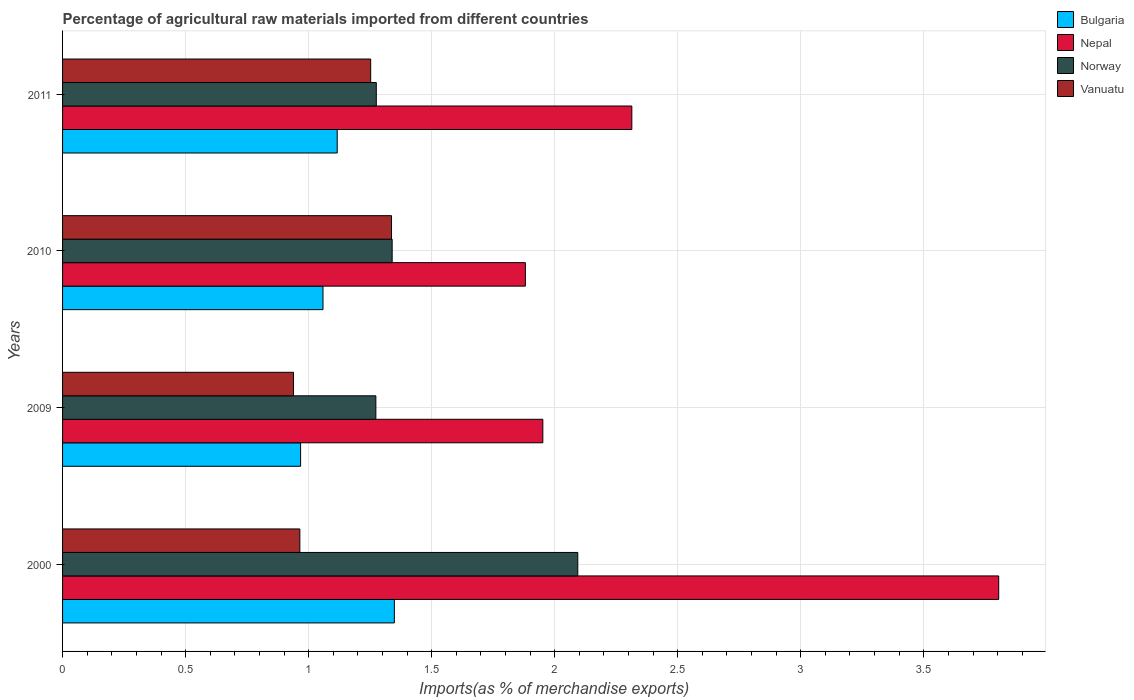How many different coloured bars are there?
Your answer should be very brief. 4. How many groups of bars are there?
Keep it short and to the point. 4. Are the number of bars per tick equal to the number of legend labels?
Make the answer very short. Yes. How many bars are there on the 2nd tick from the top?
Your response must be concise. 4. How many bars are there on the 1st tick from the bottom?
Give a very brief answer. 4. What is the label of the 2nd group of bars from the top?
Keep it short and to the point. 2010. In how many cases, is the number of bars for a given year not equal to the number of legend labels?
Offer a terse response. 0. What is the percentage of imports to different countries in Vanuatu in 2009?
Your answer should be very brief. 0.94. Across all years, what is the maximum percentage of imports to different countries in Nepal?
Offer a very short reply. 3.8. Across all years, what is the minimum percentage of imports to different countries in Vanuatu?
Your answer should be very brief. 0.94. In which year was the percentage of imports to different countries in Vanuatu minimum?
Keep it short and to the point. 2009. What is the total percentage of imports to different countries in Vanuatu in the graph?
Give a very brief answer. 4.49. What is the difference between the percentage of imports to different countries in Bulgaria in 2000 and that in 2011?
Ensure brevity in your answer.  0.23. What is the difference between the percentage of imports to different countries in Bulgaria in 2009 and the percentage of imports to different countries in Norway in 2011?
Your answer should be very brief. -0.31. What is the average percentage of imports to different countries in Norway per year?
Make the answer very short. 1.5. In the year 2000, what is the difference between the percentage of imports to different countries in Bulgaria and percentage of imports to different countries in Norway?
Provide a succinct answer. -0.75. What is the ratio of the percentage of imports to different countries in Norway in 2000 to that in 2009?
Keep it short and to the point. 1.64. Is the percentage of imports to different countries in Bulgaria in 2000 less than that in 2011?
Ensure brevity in your answer.  No. Is the difference between the percentage of imports to different countries in Bulgaria in 2009 and 2011 greater than the difference between the percentage of imports to different countries in Norway in 2009 and 2011?
Provide a short and direct response. No. What is the difference between the highest and the second highest percentage of imports to different countries in Nepal?
Ensure brevity in your answer.  1.49. What is the difference between the highest and the lowest percentage of imports to different countries in Nepal?
Your answer should be very brief. 1.92. What does the 3rd bar from the top in 2010 represents?
Provide a short and direct response. Nepal. How many years are there in the graph?
Ensure brevity in your answer.  4. Does the graph contain any zero values?
Offer a very short reply. No. Does the graph contain grids?
Keep it short and to the point. Yes. Where does the legend appear in the graph?
Offer a terse response. Top right. How many legend labels are there?
Keep it short and to the point. 4. How are the legend labels stacked?
Your answer should be compact. Vertical. What is the title of the graph?
Offer a very short reply. Percentage of agricultural raw materials imported from different countries. Does "Eritrea" appear as one of the legend labels in the graph?
Ensure brevity in your answer.  No. What is the label or title of the X-axis?
Your response must be concise. Imports(as % of merchandise exports). What is the label or title of the Y-axis?
Make the answer very short. Years. What is the Imports(as % of merchandise exports) in Bulgaria in 2000?
Make the answer very short. 1.35. What is the Imports(as % of merchandise exports) in Nepal in 2000?
Your answer should be very brief. 3.8. What is the Imports(as % of merchandise exports) of Norway in 2000?
Give a very brief answer. 2.09. What is the Imports(as % of merchandise exports) in Vanuatu in 2000?
Your answer should be very brief. 0.96. What is the Imports(as % of merchandise exports) in Bulgaria in 2009?
Provide a short and direct response. 0.97. What is the Imports(as % of merchandise exports) in Nepal in 2009?
Provide a short and direct response. 1.95. What is the Imports(as % of merchandise exports) in Norway in 2009?
Your response must be concise. 1.27. What is the Imports(as % of merchandise exports) in Vanuatu in 2009?
Offer a terse response. 0.94. What is the Imports(as % of merchandise exports) of Bulgaria in 2010?
Offer a terse response. 1.06. What is the Imports(as % of merchandise exports) in Nepal in 2010?
Ensure brevity in your answer.  1.88. What is the Imports(as % of merchandise exports) in Norway in 2010?
Provide a succinct answer. 1.34. What is the Imports(as % of merchandise exports) of Vanuatu in 2010?
Offer a very short reply. 1.34. What is the Imports(as % of merchandise exports) in Bulgaria in 2011?
Provide a succinct answer. 1.12. What is the Imports(as % of merchandise exports) of Nepal in 2011?
Your answer should be very brief. 2.31. What is the Imports(as % of merchandise exports) of Norway in 2011?
Provide a short and direct response. 1.27. What is the Imports(as % of merchandise exports) of Vanuatu in 2011?
Make the answer very short. 1.25. Across all years, what is the maximum Imports(as % of merchandise exports) of Bulgaria?
Give a very brief answer. 1.35. Across all years, what is the maximum Imports(as % of merchandise exports) in Nepal?
Make the answer very short. 3.8. Across all years, what is the maximum Imports(as % of merchandise exports) of Norway?
Offer a terse response. 2.09. Across all years, what is the maximum Imports(as % of merchandise exports) of Vanuatu?
Your answer should be very brief. 1.34. Across all years, what is the minimum Imports(as % of merchandise exports) of Bulgaria?
Offer a very short reply. 0.97. Across all years, what is the minimum Imports(as % of merchandise exports) of Nepal?
Your answer should be compact. 1.88. Across all years, what is the minimum Imports(as % of merchandise exports) in Norway?
Offer a very short reply. 1.27. Across all years, what is the minimum Imports(as % of merchandise exports) of Vanuatu?
Provide a short and direct response. 0.94. What is the total Imports(as % of merchandise exports) of Bulgaria in the graph?
Give a very brief answer. 4.49. What is the total Imports(as % of merchandise exports) of Nepal in the graph?
Give a very brief answer. 9.95. What is the total Imports(as % of merchandise exports) in Norway in the graph?
Your answer should be compact. 5.98. What is the total Imports(as % of merchandise exports) in Vanuatu in the graph?
Make the answer very short. 4.49. What is the difference between the Imports(as % of merchandise exports) in Bulgaria in 2000 and that in 2009?
Ensure brevity in your answer.  0.38. What is the difference between the Imports(as % of merchandise exports) in Nepal in 2000 and that in 2009?
Your answer should be compact. 1.85. What is the difference between the Imports(as % of merchandise exports) of Norway in 2000 and that in 2009?
Your answer should be compact. 0.82. What is the difference between the Imports(as % of merchandise exports) in Vanuatu in 2000 and that in 2009?
Give a very brief answer. 0.03. What is the difference between the Imports(as % of merchandise exports) of Bulgaria in 2000 and that in 2010?
Offer a very short reply. 0.29. What is the difference between the Imports(as % of merchandise exports) of Nepal in 2000 and that in 2010?
Provide a succinct answer. 1.92. What is the difference between the Imports(as % of merchandise exports) in Norway in 2000 and that in 2010?
Your answer should be compact. 0.75. What is the difference between the Imports(as % of merchandise exports) in Vanuatu in 2000 and that in 2010?
Make the answer very short. -0.37. What is the difference between the Imports(as % of merchandise exports) of Bulgaria in 2000 and that in 2011?
Your response must be concise. 0.23. What is the difference between the Imports(as % of merchandise exports) in Nepal in 2000 and that in 2011?
Your answer should be very brief. 1.49. What is the difference between the Imports(as % of merchandise exports) of Norway in 2000 and that in 2011?
Provide a short and direct response. 0.82. What is the difference between the Imports(as % of merchandise exports) in Vanuatu in 2000 and that in 2011?
Provide a succinct answer. -0.29. What is the difference between the Imports(as % of merchandise exports) of Bulgaria in 2009 and that in 2010?
Give a very brief answer. -0.09. What is the difference between the Imports(as % of merchandise exports) in Nepal in 2009 and that in 2010?
Offer a terse response. 0.07. What is the difference between the Imports(as % of merchandise exports) of Norway in 2009 and that in 2010?
Make the answer very short. -0.07. What is the difference between the Imports(as % of merchandise exports) in Vanuatu in 2009 and that in 2010?
Offer a terse response. -0.4. What is the difference between the Imports(as % of merchandise exports) in Bulgaria in 2009 and that in 2011?
Keep it short and to the point. -0.15. What is the difference between the Imports(as % of merchandise exports) in Nepal in 2009 and that in 2011?
Provide a succinct answer. -0.36. What is the difference between the Imports(as % of merchandise exports) in Norway in 2009 and that in 2011?
Make the answer very short. -0. What is the difference between the Imports(as % of merchandise exports) of Vanuatu in 2009 and that in 2011?
Your answer should be very brief. -0.31. What is the difference between the Imports(as % of merchandise exports) of Bulgaria in 2010 and that in 2011?
Give a very brief answer. -0.06. What is the difference between the Imports(as % of merchandise exports) of Nepal in 2010 and that in 2011?
Offer a terse response. -0.43. What is the difference between the Imports(as % of merchandise exports) of Norway in 2010 and that in 2011?
Your answer should be compact. 0.06. What is the difference between the Imports(as % of merchandise exports) of Vanuatu in 2010 and that in 2011?
Ensure brevity in your answer.  0.08. What is the difference between the Imports(as % of merchandise exports) of Bulgaria in 2000 and the Imports(as % of merchandise exports) of Nepal in 2009?
Ensure brevity in your answer.  -0.6. What is the difference between the Imports(as % of merchandise exports) of Bulgaria in 2000 and the Imports(as % of merchandise exports) of Norway in 2009?
Your answer should be very brief. 0.08. What is the difference between the Imports(as % of merchandise exports) in Bulgaria in 2000 and the Imports(as % of merchandise exports) in Vanuatu in 2009?
Give a very brief answer. 0.41. What is the difference between the Imports(as % of merchandise exports) of Nepal in 2000 and the Imports(as % of merchandise exports) of Norway in 2009?
Provide a short and direct response. 2.53. What is the difference between the Imports(as % of merchandise exports) of Nepal in 2000 and the Imports(as % of merchandise exports) of Vanuatu in 2009?
Ensure brevity in your answer.  2.87. What is the difference between the Imports(as % of merchandise exports) of Norway in 2000 and the Imports(as % of merchandise exports) of Vanuatu in 2009?
Your answer should be compact. 1.16. What is the difference between the Imports(as % of merchandise exports) in Bulgaria in 2000 and the Imports(as % of merchandise exports) in Nepal in 2010?
Offer a very short reply. -0.53. What is the difference between the Imports(as % of merchandise exports) of Bulgaria in 2000 and the Imports(as % of merchandise exports) of Norway in 2010?
Make the answer very short. 0.01. What is the difference between the Imports(as % of merchandise exports) in Bulgaria in 2000 and the Imports(as % of merchandise exports) in Vanuatu in 2010?
Ensure brevity in your answer.  0.01. What is the difference between the Imports(as % of merchandise exports) of Nepal in 2000 and the Imports(as % of merchandise exports) of Norway in 2010?
Make the answer very short. 2.46. What is the difference between the Imports(as % of merchandise exports) in Nepal in 2000 and the Imports(as % of merchandise exports) in Vanuatu in 2010?
Make the answer very short. 2.47. What is the difference between the Imports(as % of merchandise exports) in Norway in 2000 and the Imports(as % of merchandise exports) in Vanuatu in 2010?
Make the answer very short. 0.76. What is the difference between the Imports(as % of merchandise exports) of Bulgaria in 2000 and the Imports(as % of merchandise exports) of Nepal in 2011?
Provide a short and direct response. -0.97. What is the difference between the Imports(as % of merchandise exports) of Bulgaria in 2000 and the Imports(as % of merchandise exports) of Norway in 2011?
Give a very brief answer. 0.07. What is the difference between the Imports(as % of merchandise exports) in Bulgaria in 2000 and the Imports(as % of merchandise exports) in Vanuatu in 2011?
Your answer should be very brief. 0.1. What is the difference between the Imports(as % of merchandise exports) of Nepal in 2000 and the Imports(as % of merchandise exports) of Norway in 2011?
Your answer should be very brief. 2.53. What is the difference between the Imports(as % of merchandise exports) of Nepal in 2000 and the Imports(as % of merchandise exports) of Vanuatu in 2011?
Provide a short and direct response. 2.55. What is the difference between the Imports(as % of merchandise exports) of Norway in 2000 and the Imports(as % of merchandise exports) of Vanuatu in 2011?
Provide a succinct answer. 0.84. What is the difference between the Imports(as % of merchandise exports) of Bulgaria in 2009 and the Imports(as % of merchandise exports) of Nepal in 2010?
Provide a succinct answer. -0.91. What is the difference between the Imports(as % of merchandise exports) in Bulgaria in 2009 and the Imports(as % of merchandise exports) in Norway in 2010?
Offer a terse response. -0.37. What is the difference between the Imports(as % of merchandise exports) in Bulgaria in 2009 and the Imports(as % of merchandise exports) in Vanuatu in 2010?
Keep it short and to the point. -0.37. What is the difference between the Imports(as % of merchandise exports) in Nepal in 2009 and the Imports(as % of merchandise exports) in Norway in 2010?
Make the answer very short. 0.61. What is the difference between the Imports(as % of merchandise exports) of Nepal in 2009 and the Imports(as % of merchandise exports) of Vanuatu in 2010?
Your answer should be very brief. 0.61. What is the difference between the Imports(as % of merchandise exports) of Norway in 2009 and the Imports(as % of merchandise exports) of Vanuatu in 2010?
Offer a very short reply. -0.06. What is the difference between the Imports(as % of merchandise exports) in Bulgaria in 2009 and the Imports(as % of merchandise exports) in Nepal in 2011?
Keep it short and to the point. -1.35. What is the difference between the Imports(as % of merchandise exports) of Bulgaria in 2009 and the Imports(as % of merchandise exports) of Norway in 2011?
Keep it short and to the point. -0.31. What is the difference between the Imports(as % of merchandise exports) in Bulgaria in 2009 and the Imports(as % of merchandise exports) in Vanuatu in 2011?
Provide a short and direct response. -0.28. What is the difference between the Imports(as % of merchandise exports) of Nepal in 2009 and the Imports(as % of merchandise exports) of Norway in 2011?
Provide a short and direct response. 0.68. What is the difference between the Imports(as % of merchandise exports) in Nepal in 2009 and the Imports(as % of merchandise exports) in Vanuatu in 2011?
Your answer should be very brief. 0.7. What is the difference between the Imports(as % of merchandise exports) of Norway in 2009 and the Imports(as % of merchandise exports) of Vanuatu in 2011?
Offer a very short reply. 0.02. What is the difference between the Imports(as % of merchandise exports) in Bulgaria in 2010 and the Imports(as % of merchandise exports) in Nepal in 2011?
Keep it short and to the point. -1.25. What is the difference between the Imports(as % of merchandise exports) of Bulgaria in 2010 and the Imports(as % of merchandise exports) of Norway in 2011?
Give a very brief answer. -0.22. What is the difference between the Imports(as % of merchandise exports) in Bulgaria in 2010 and the Imports(as % of merchandise exports) in Vanuatu in 2011?
Keep it short and to the point. -0.19. What is the difference between the Imports(as % of merchandise exports) of Nepal in 2010 and the Imports(as % of merchandise exports) of Norway in 2011?
Offer a terse response. 0.61. What is the difference between the Imports(as % of merchandise exports) of Nepal in 2010 and the Imports(as % of merchandise exports) of Vanuatu in 2011?
Ensure brevity in your answer.  0.63. What is the difference between the Imports(as % of merchandise exports) of Norway in 2010 and the Imports(as % of merchandise exports) of Vanuatu in 2011?
Your answer should be compact. 0.09. What is the average Imports(as % of merchandise exports) in Bulgaria per year?
Provide a succinct answer. 1.12. What is the average Imports(as % of merchandise exports) in Nepal per year?
Provide a short and direct response. 2.49. What is the average Imports(as % of merchandise exports) in Norway per year?
Give a very brief answer. 1.5. What is the average Imports(as % of merchandise exports) in Vanuatu per year?
Your answer should be very brief. 1.12. In the year 2000, what is the difference between the Imports(as % of merchandise exports) in Bulgaria and Imports(as % of merchandise exports) in Nepal?
Offer a very short reply. -2.46. In the year 2000, what is the difference between the Imports(as % of merchandise exports) of Bulgaria and Imports(as % of merchandise exports) of Norway?
Provide a succinct answer. -0.75. In the year 2000, what is the difference between the Imports(as % of merchandise exports) of Bulgaria and Imports(as % of merchandise exports) of Vanuatu?
Make the answer very short. 0.38. In the year 2000, what is the difference between the Imports(as % of merchandise exports) in Nepal and Imports(as % of merchandise exports) in Norway?
Offer a terse response. 1.71. In the year 2000, what is the difference between the Imports(as % of merchandise exports) of Nepal and Imports(as % of merchandise exports) of Vanuatu?
Provide a succinct answer. 2.84. In the year 2000, what is the difference between the Imports(as % of merchandise exports) of Norway and Imports(as % of merchandise exports) of Vanuatu?
Provide a short and direct response. 1.13. In the year 2009, what is the difference between the Imports(as % of merchandise exports) of Bulgaria and Imports(as % of merchandise exports) of Nepal?
Provide a succinct answer. -0.98. In the year 2009, what is the difference between the Imports(as % of merchandise exports) of Bulgaria and Imports(as % of merchandise exports) of Norway?
Provide a short and direct response. -0.31. In the year 2009, what is the difference between the Imports(as % of merchandise exports) of Bulgaria and Imports(as % of merchandise exports) of Vanuatu?
Make the answer very short. 0.03. In the year 2009, what is the difference between the Imports(as % of merchandise exports) in Nepal and Imports(as % of merchandise exports) in Norway?
Offer a terse response. 0.68. In the year 2009, what is the difference between the Imports(as % of merchandise exports) in Nepal and Imports(as % of merchandise exports) in Vanuatu?
Your answer should be compact. 1.01. In the year 2009, what is the difference between the Imports(as % of merchandise exports) of Norway and Imports(as % of merchandise exports) of Vanuatu?
Your response must be concise. 0.33. In the year 2010, what is the difference between the Imports(as % of merchandise exports) in Bulgaria and Imports(as % of merchandise exports) in Nepal?
Your response must be concise. -0.82. In the year 2010, what is the difference between the Imports(as % of merchandise exports) of Bulgaria and Imports(as % of merchandise exports) of Norway?
Your response must be concise. -0.28. In the year 2010, what is the difference between the Imports(as % of merchandise exports) in Bulgaria and Imports(as % of merchandise exports) in Vanuatu?
Your answer should be compact. -0.28. In the year 2010, what is the difference between the Imports(as % of merchandise exports) of Nepal and Imports(as % of merchandise exports) of Norway?
Ensure brevity in your answer.  0.54. In the year 2010, what is the difference between the Imports(as % of merchandise exports) in Nepal and Imports(as % of merchandise exports) in Vanuatu?
Give a very brief answer. 0.54. In the year 2010, what is the difference between the Imports(as % of merchandise exports) in Norway and Imports(as % of merchandise exports) in Vanuatu?
Your answer should be compact. 0. In the year 2011, what is the difference between the Imports(as % of merchandise exports) in Bulgaria and Imports(as % of merchandise exports) in Nepal?
Your answer should be very brief. -1.2. In the year 2011, what is the difference between the Imports(as % of merchandise exports) of Bulgaria and Imports(as % of merchandise exports) of Norway?
Your response must be concise. -0.16. In the year 2011, what is the difference between the Imports(as % of merchandise exports) in Bulgaria and Imports(as % of merchandise exports) in Vanuatu?
Keep it short and to the point. -0.14. In the year 2011, what is the difference between the Imports(as % of merchandise exports) of Nepal and Imports(as % of merchandise exports) of Norway?
Your answer should be very brief. 1.04. In the year 2011, what is the difference between the Imports(as % of merchandise exports) of Nepal and Imports(as % of merchandise exports) of Vanuatu?
Keep it short and to the point. 1.06. In the year 2011, what is the difference between the Imports(as % of merchandise exports) in Norway and Imports(as % of merchandise exports) in Vanuatu?
Ensure brevity in your answer.  0.02. What is the ratio of the Imports(as % of merchandise exports) in Bulgaria in 2000 to that in 2009?
Your answer should be compact. 1.39. What is the ratio of the Imports(as % of merchandise exports) of Nepal in 2000 to that in 2009?
Provide a short and direct response. 1.95. What is the ratio of the Imports(as % of merchandise exports) of Norway in 2000 to that in 2009?
Provide a short and direct response. 1.64. What is the ratio of the Imports(as % of merchandise exports) of Vanuatu in 2000 to that in 2009?
Provide a succinct answer. 1.03. What is the ratio of the Imports(as % of merchandise exports) of Bulgaria in 2000 to that in 2010?
Give a very brief answer. 1.27. What is the ratio of the Imports(as % of merchandise exports) in Nepal in 2000 to that in 2010?
Provide a succinct answer. 2.02. What is the ratio of the Imports(as % of merchandise exports) of Norway in 2000 to that in 2010?
Ensure brevity in your answer.  1.56. What is the ratio of the Imports(as % of merchandise exports) of Vanuatu in 2000 to that in 2010?
Provide a short and direct response. 0.72. What is the ratio of the Imports(as % of merchandise exports) in Bulgaria in 2000 to that in 2011?
Make the answer very short. 1.21. What is the ratio of the Imports(as % of merchandise exports) of Nepal in 2000 to that in 2011?
Make the answer very short. 1.64. What is the ratio of the Imports(as % of merchandise exports) in Norway in 2000 to that in 2011?
Make the answer very short. 1.64. What is the ratio of the Imports(as % of merchandise exports) of Vanuatu in 2000 to that in 2011?
Provide a succinct answer. 0.77. What is the ratio of the Imports(as % of merchandise exports) in Bulgaria in 2009 to that in 2010?
Your answer should be very brief. 0.91. What is the ratio of the Imports(as % of merchandise exports) of Nepal in 2009 to that in 2010?
Your answer should be very brief. 1.04. What is the ratio of the Imports(as % of merchandise exports) in Norway in 2009 to that in 2010?
Give a very brief answer. 0.95. What is the ratio of the Imports(as % of merchandise exports) of Vanuatu in 2009 to that in 2010?
Ensure brevity in your answer.  0.7. What is the ratio of the Imports(as % of merchandise exports) of Bulgaria in 2009 to that in 2011?
Offer a very short reply. 0.87. What is the ratio of the Imports(as % of merchandise exports) of Nepal in 2009 to that in 2011?
Ensure brevity in your answer.  0.84. What is the ratio of the Imports(as % of merchandise exports) of Vanuatu in 2009 to that in 2011?
Provide a succinct answer. 0.75. What is the ratio of the Imports(as % of merchandise exports) in Bulgaria in 2010 to that in 2011?
Offer a terse response. 0.95. What is the ratio of the Imports(as % of merchandise exports) of Nepal in 2010 to that in 2011?
Your answer should be very brief. 0.81. What is the ratio of the Imports(as % of merchandise exports) in Norway in 2010 to that in 2011?
Offer a very short reply. 1.05. What is the ratio of the Imports(as % of merchandise exports) in Vanuatu in 2010 to that in 2011?
Offer a very short reply. 1.07. What is the difference between the highest and the second highest Imports(as % of merchandise exports) of Bulgaria?
Ensure brevity in your answer.  0.23. What is the difference between the highest and the second highest Imports(as % of merchandise exports) in Nepal?
Make the answer very short. 1.49. What is the difference between the highest and the second highest Imports(as % of merchandise exports) of Norway?
Offer a very short reply. 0.75. What is the difference between the highest and the second highest Imports(as % of merchandise exports) in Vanuatu?
Make the answer very short. 0.08. What is the difference between the highest and the lowest Imports(as % of merchandise exports) in Bulgaria?
Give a very brief answer. 0.38. What is the difference between the highest and the lowest Imports(as % of merchandise exports) in Nepal?
Provide a short and direct response. 1.92. What is the difference between the highest and the lowest Imports(as % of merchandise exports) of Norway?
Give a very brief answer. 0.82. What is the difference between the highest and the lowest Imports(as % of merchandise exports) of Vanuatu?
Offer a terse response. 0.4. 